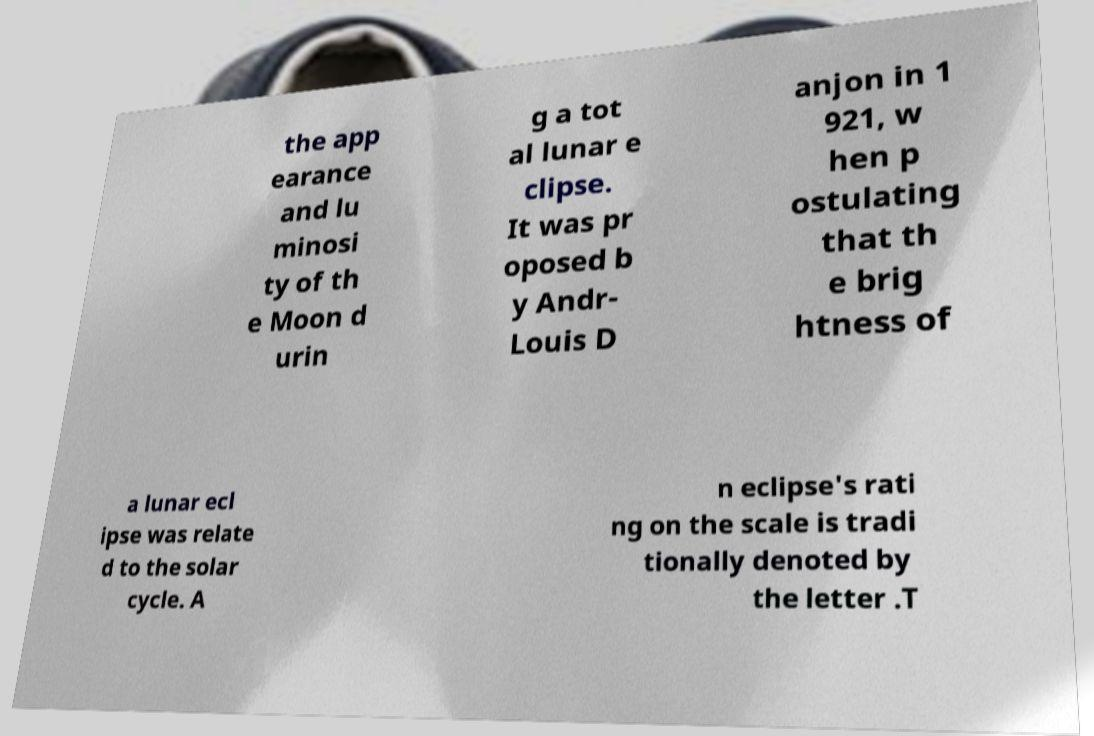Please read and relay the text visible in this image. What does it say? the app earance and lu minosi ty of th e Moon d urin g a tot al lunar e clipse. It was pr oposed b y Andr- Louis D anjon in 1 921, w hen p ostulating that th e brig htness of a lunar ecl ipse was relate d to the solar cycle. A n eclipse's rati ng on the scale is tradi tionally denoted by the letter .T 